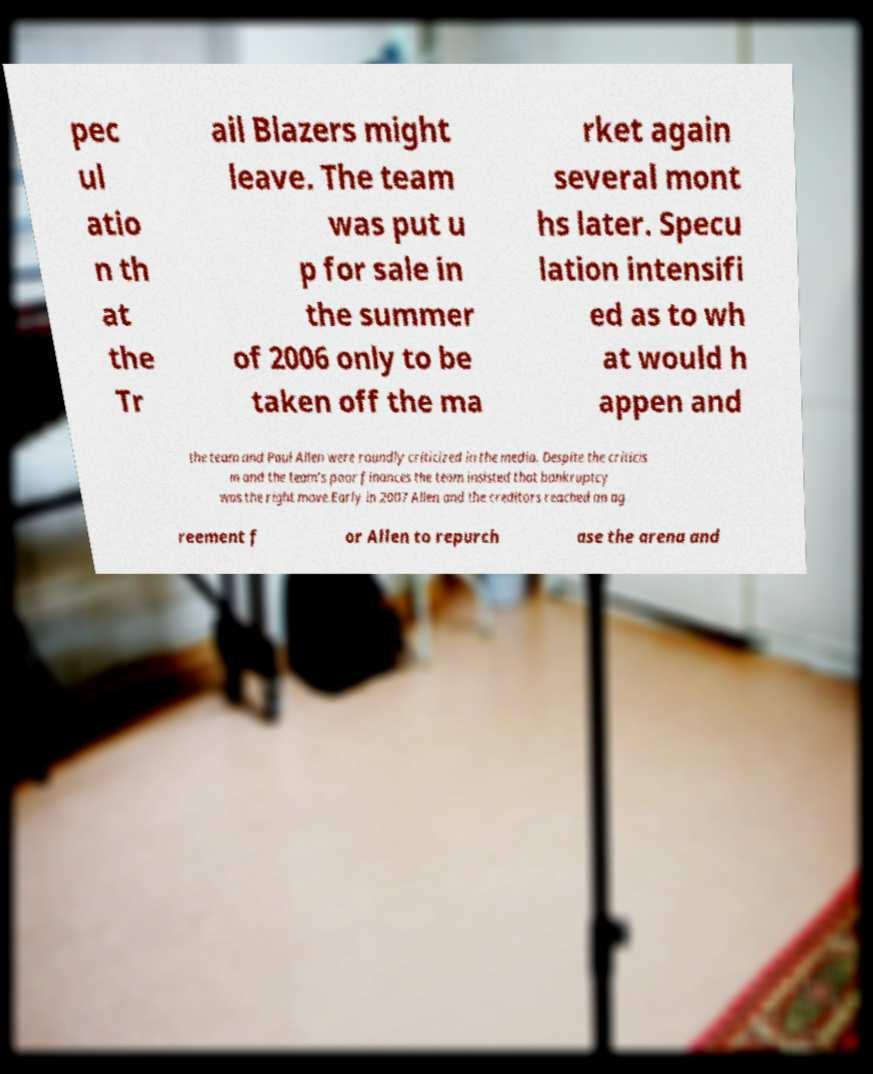There's text embedded in this image that I need extracted. Can you transcribe it verbatim? pec ul atio n th at the Tr ail Blazers might leave. The team was put u p for sale in the summer of 2006 only to be taken off the ma rket again several mont hs later. Specu lation intensifi ed as to wh at would h appen and the team and Paul Allen were roundly criticized in the media. Despite the criticis m and the team's poor finances the team insisted that bankruptcy was the right move.Early in 2007 Allen and the creditors reached an ag reement f or Allen to repurch ase the arena and 